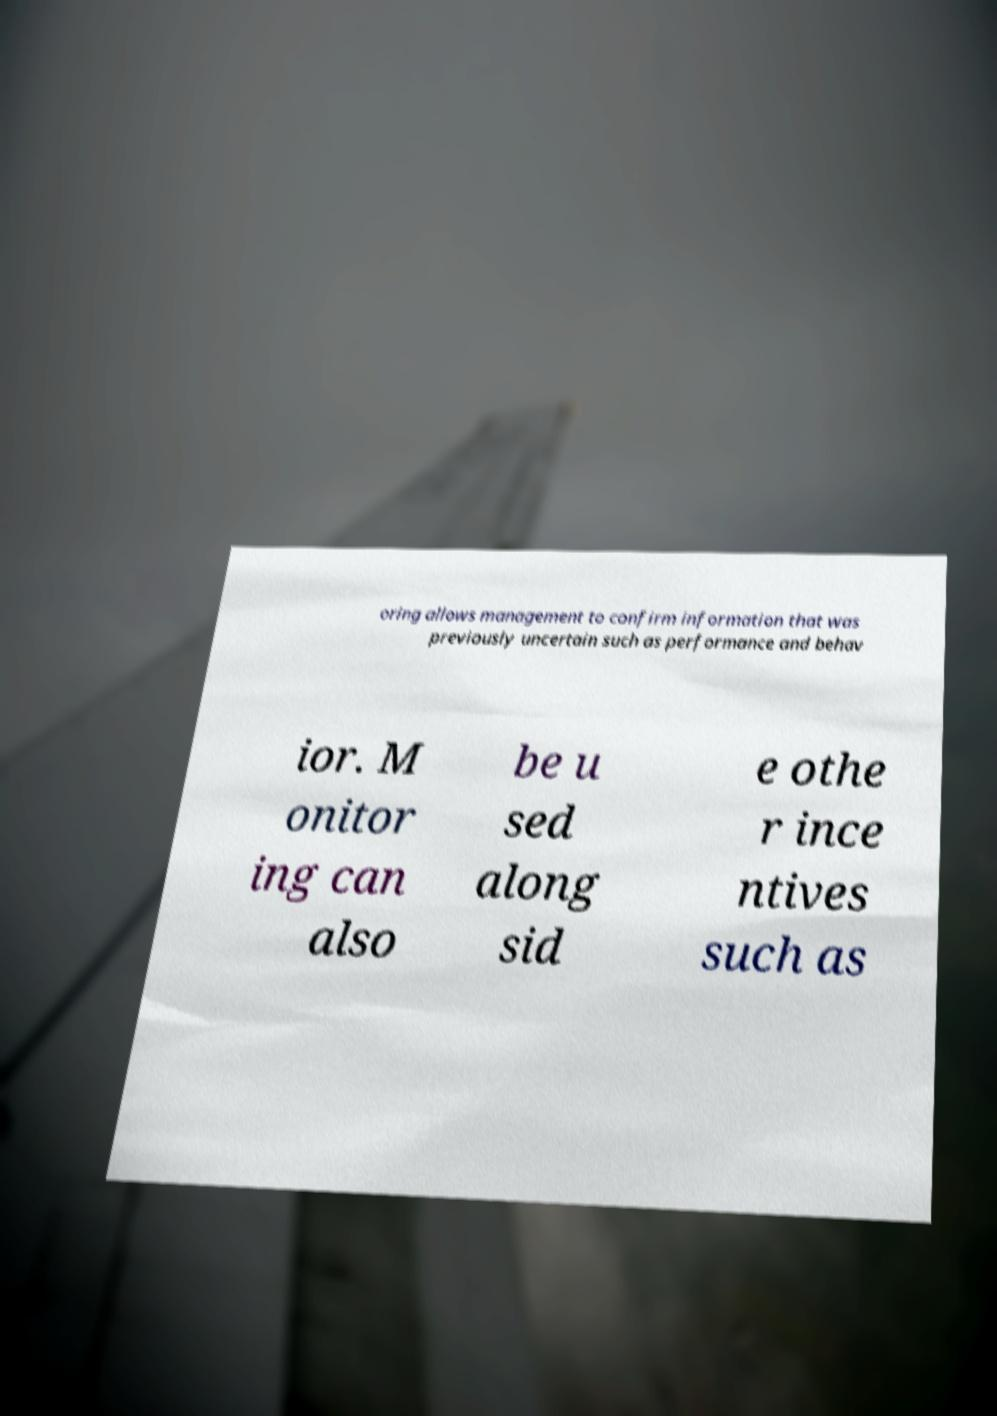What messages or text are displayed in this image? I need them in a readable, typed format. oring allows management to confirm information that was previously uncertain such as performance and behav ior. M onitor ing can also be u sed along sid e othe r ince ntives such as 